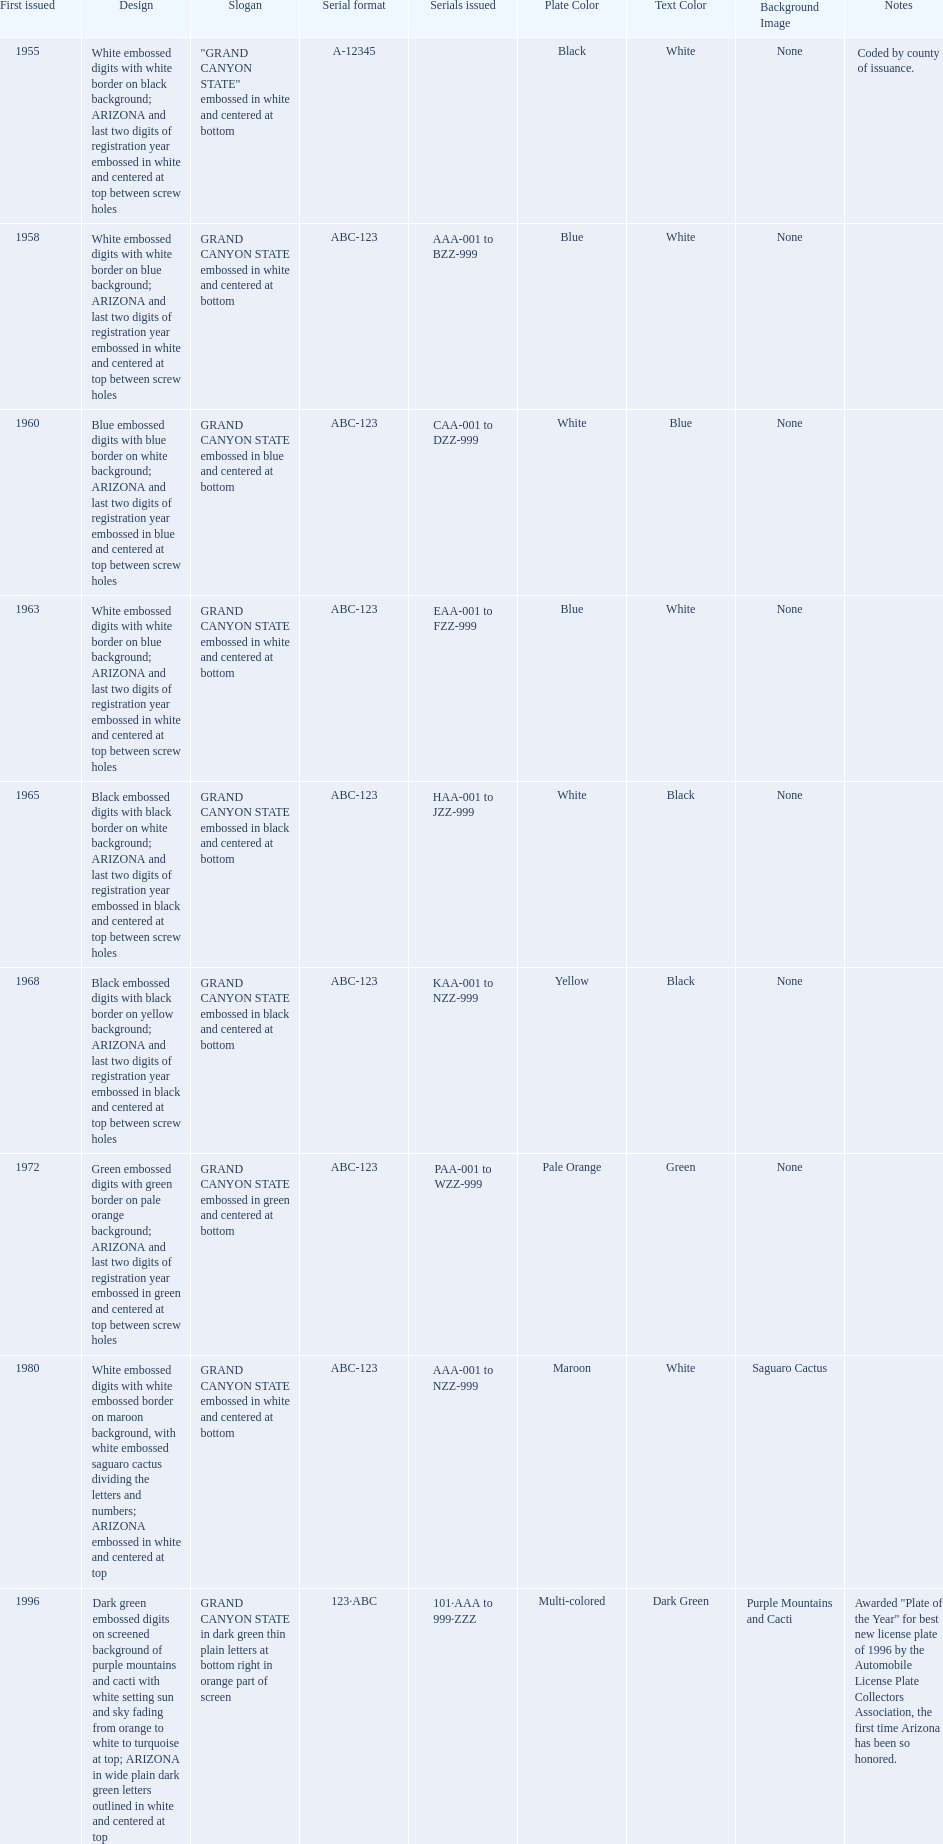Which year featured the license plate with the least characters? 1955. 